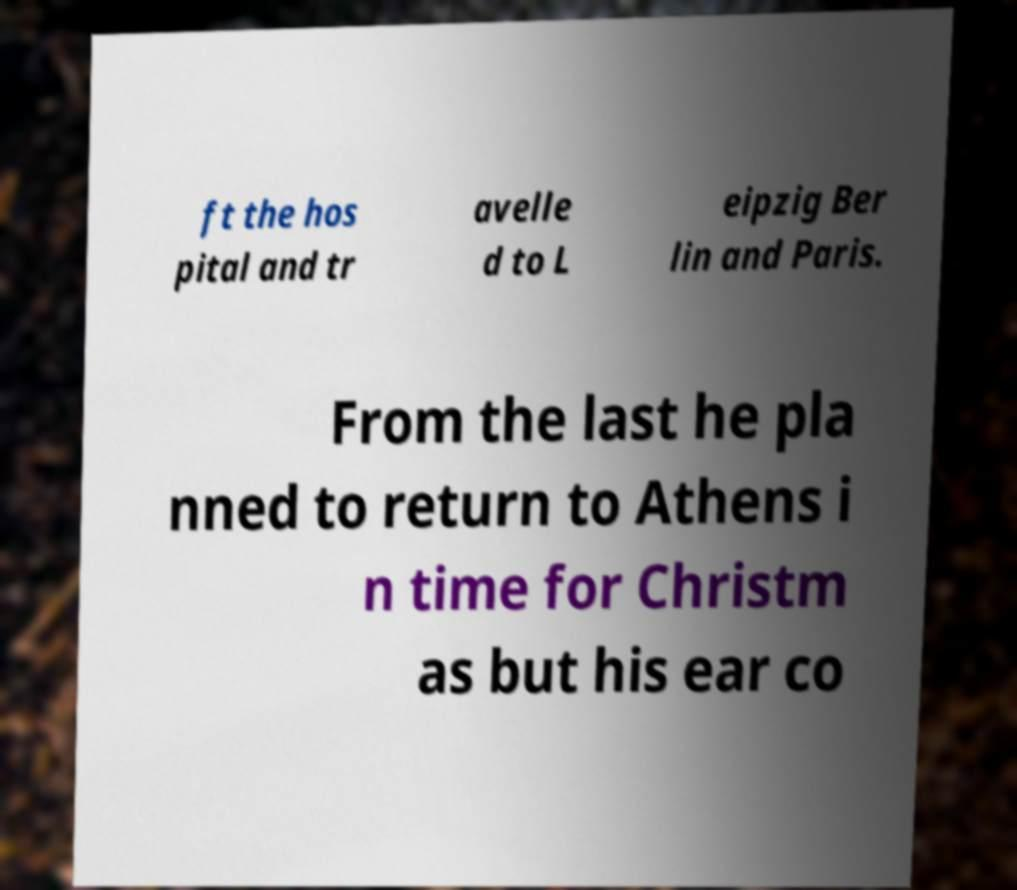Could you assist in decoding the text presented in this image and type it out clearly? ft the hos pital and tr avelle d to L eipzig Ber lin and Paris. From the last he pla nned to return to Athens i n time for Christm as but his ear co 